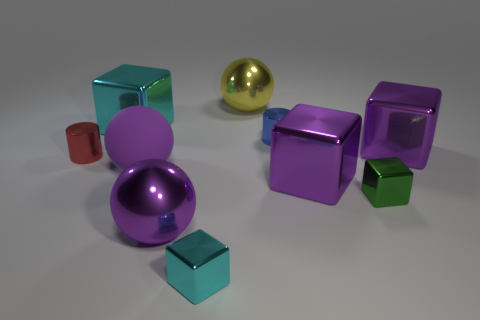Add 6 large purple cubes. How many large purple cubes exist? 8 Subtract all green cubes. How many cubes are left? 4 Subtract all big cyan blocks. How many blocks are left? 4 Subtract 1 yellow spheres. How many objects are left? 9 Subtract all cylinders. How many objects are left? 8 Subtract 4 blocks. How many blocks are left? 1 Subtract all red cylinders. Subtract all green balls. How many cylinders are left? 1 Subtract all brown spheres. How many purple blocks are left? 2 Subtract all large rubber balls. Subtract all large metallic balls. How many objects are left? 7 Add 2 large cyan things. How many large cyan things are left? 3 